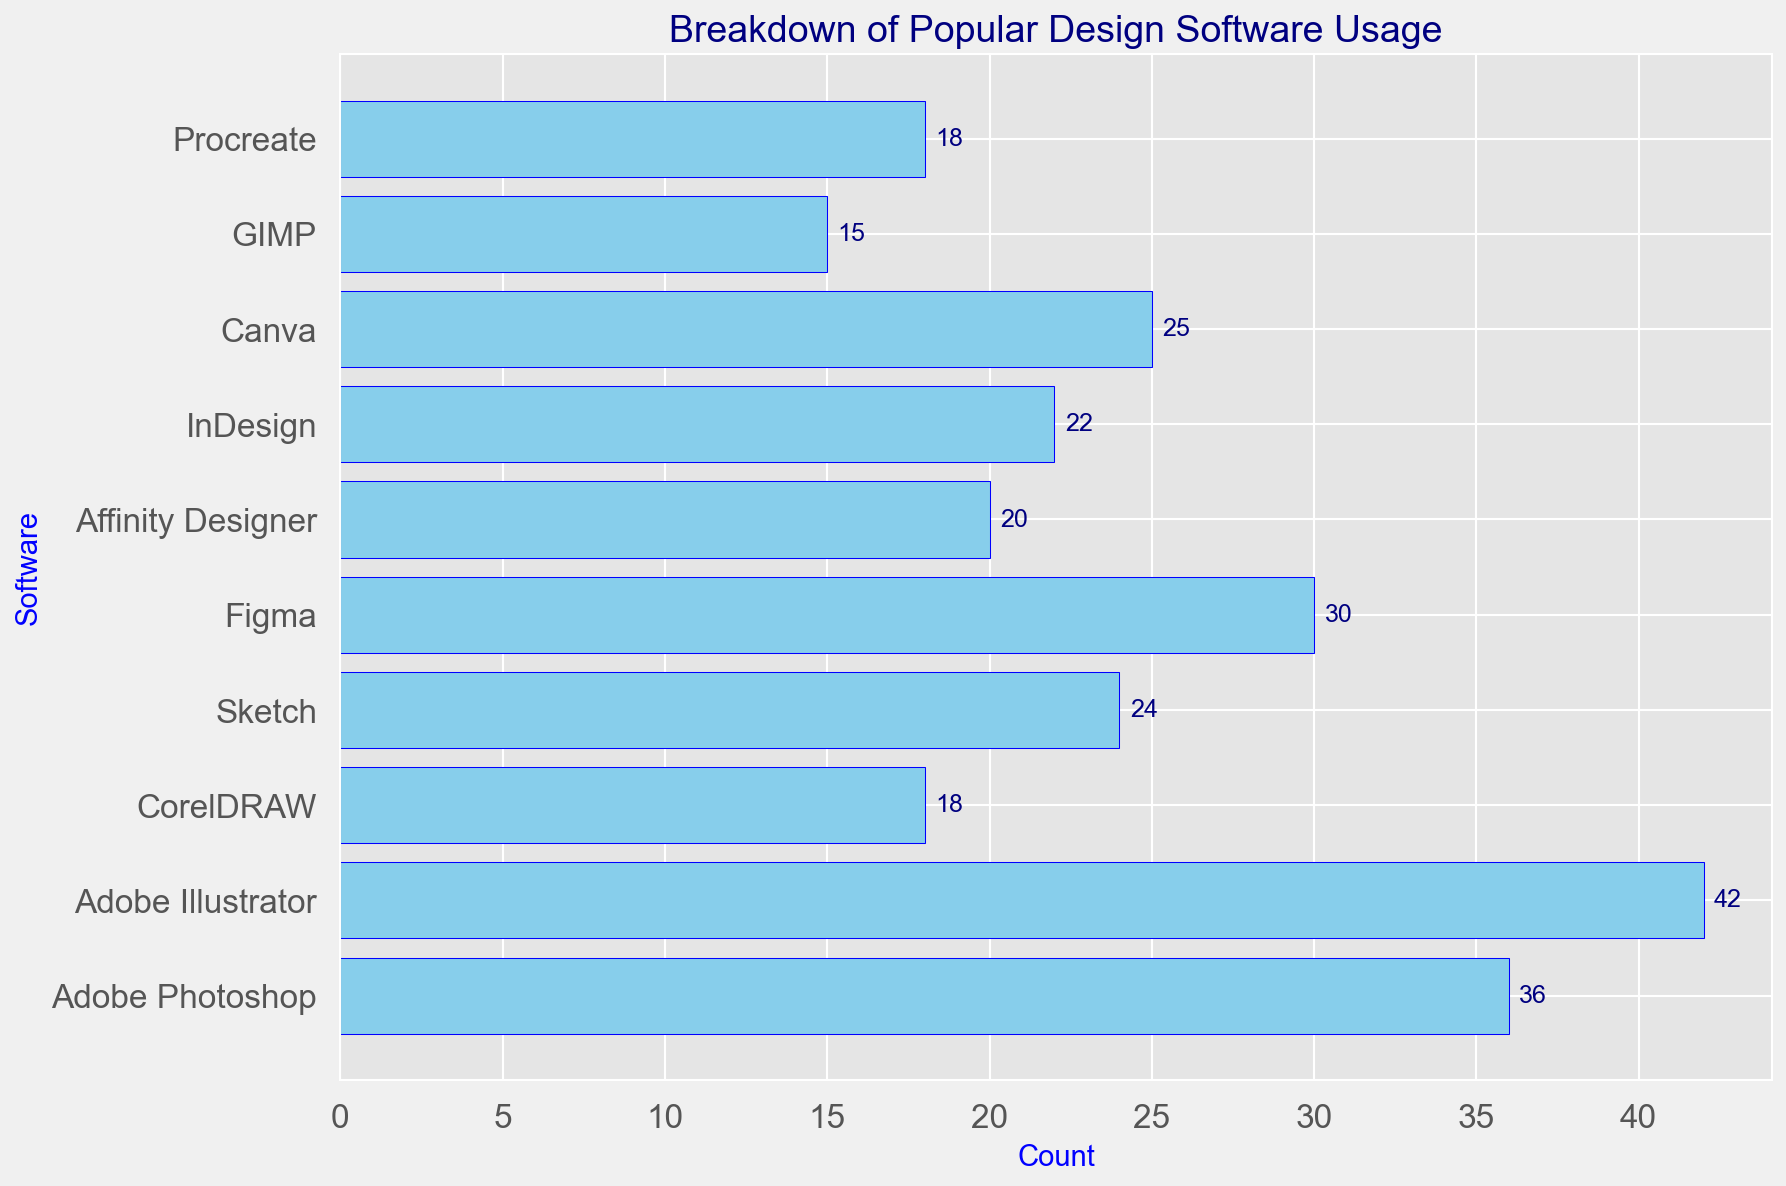Which software has the highest usage count? The highest bar represents the software with the highest usage count. By identifying the longest bar, we can see that Adobe Illustrator has the highest count.
Answer: Adobe Illustrator Which software has the lowest usage count? The shortest bar indicates the software with the lowest usage count. From the graph, we can see this is GIMP.
Answer: GIMP What is the total usage count of Adobe software (Photoshop, Illustrator, and InDesign combined)? Add the individual counts for each Adobe software: Adobe Photoshop (36) + Adobe Illustrator (42) + InDesign (22). Summing these gives 36 + 42 + 22 = 100.
Answer: 100 How does the count of Figma compare to the count of Sketch? Look at the bar heights for Figma and Sketch. Figma has a count of 30, and Sketch has a count of 24. Figma's count is higher.
Answer: Figma Which software has a usage count greater than 30 but less than 40? Identify bars whose heights fall between 30 and 40. Only Adobe Photoshop meets this criterion with a count of 36.
Answer: Adobe Photoshop What is the average usage count of all the software listed? Sum all the counts and divide by the number of software items. The total is 36 (Photoshop) + 42 (Illustrator) + 18 (CorelDRAW) + 24 (Sketch) + 30 (Figma) + 20 (Affinity Designer) + 22 (InDesign) + 25 (Canva) + 15 (GIMP) + 18 (Procreate) = 250. Dividing by 10 gives 250/10 = 25.
Answer: 25 How many software have a higher usage count than Affinity Designer? Identify the bars higher than Affinity Designer, which has a count of 20. Those are Adobe Photoshop (36), Adobe Illustrator (42), Sketch (24), Figma (30), InDesign (22), and Canva (25). That's six software.
Answer: 6 What is the difference in usage count between Procreate and CorelDRAW? Subtract the count of CorelDRAW (18) from Procreate (18). The difference is 18 - 18, which is 0.
Answer: 0 What is the median usage count of the listed software? First, order the counts: 15, 18, 18, 20, 22, 24, 25, 30, 36, 42. The median is the average of the 5th and 6th values (22 and 24). (22 + 24) / 2 = 23.
Answer: 23 